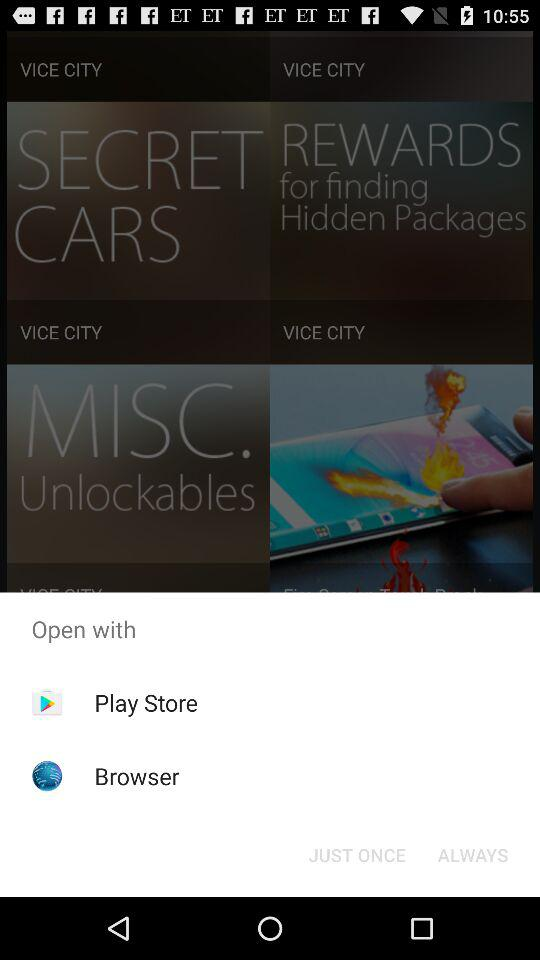What are the different available options to open? The different available options are "Play Store" and "Browser". 